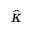Convert formula to latex. <formula><loc_0><loc_0><loc_500><loc_500>\hat { \kappa }</formula> 